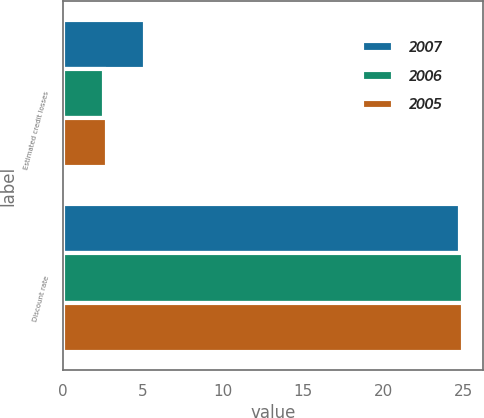Convert chart to OTSL. <chart><loc_0><loc_0><loc_500><loc_500><stacked_bar_chart><ecel><fcel>Estimated credit losses<fcel>Discount rate<nl><fcel>2007<fcel>5.09<fcel>24.79<nl><fcel>2006<fcel>2.55<fcel>25<nl><fcel>2005<fcel>2.72<fcel>25<nl></chart> 